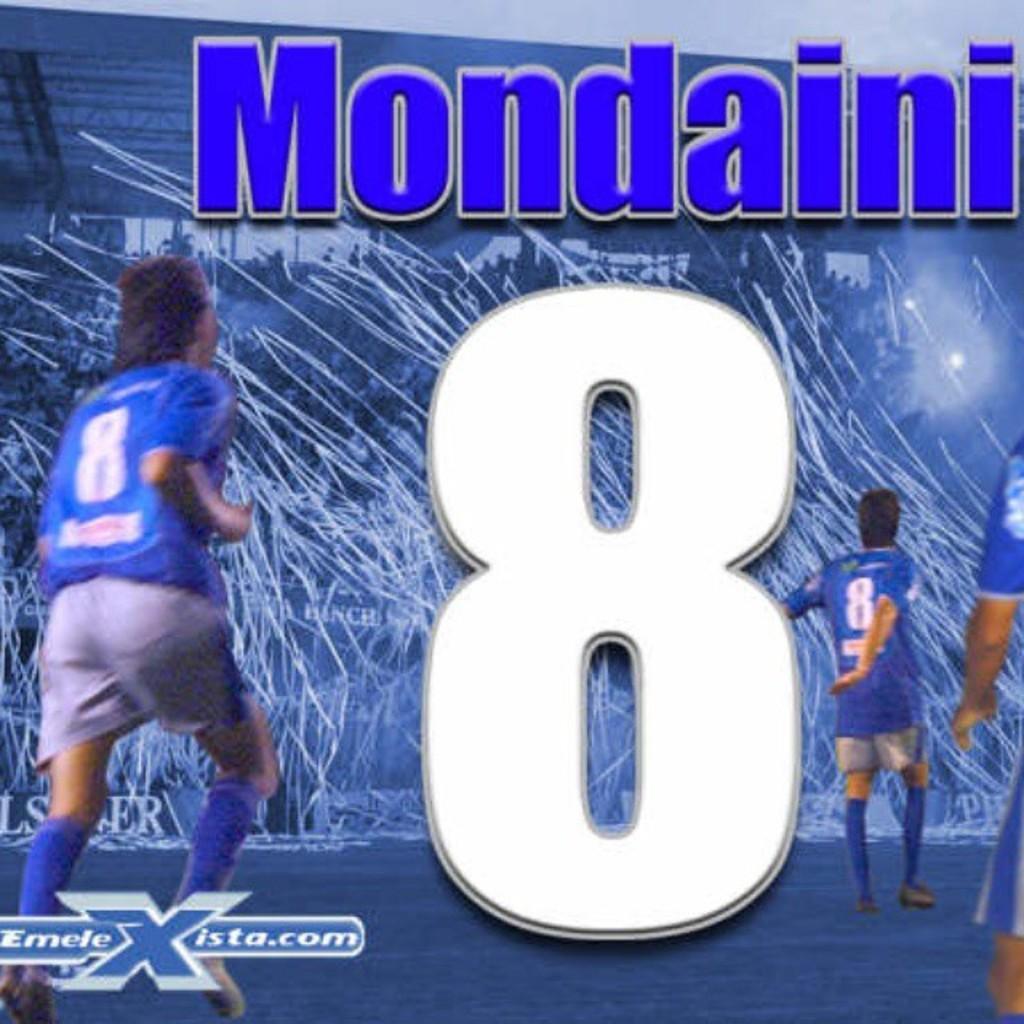How would you summarize this image in a sentence or two? In this image I can see three people with blue color dresses. In the background I can see the lights and the stadium. I can see something is written on it. 